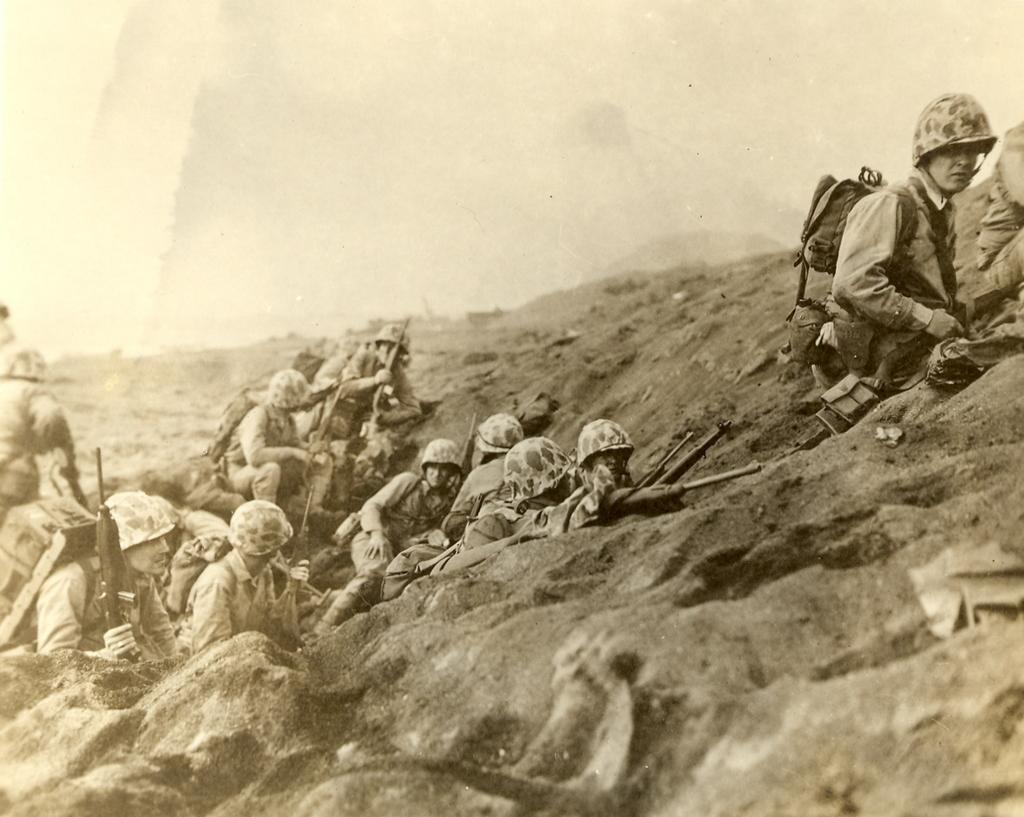What is the main subject of the image? The main subject of the image is a group of people. Where are the people located in the image? The group of people is on a hill area. What are the people wearing in the image? The people are wearing helmets. What are the people holding in the image? The people are holding guns. What can be seen in the background of the image? The sky is visible in the background of the image. What type of form can be seen floating on the water in the image? There is no form or water present in the image; it features a group of people on a hill area. What kind of island can be seen in the background of the image? There is no island visible in the image; it only shows a group of people on a hill area with the sky in the background. 